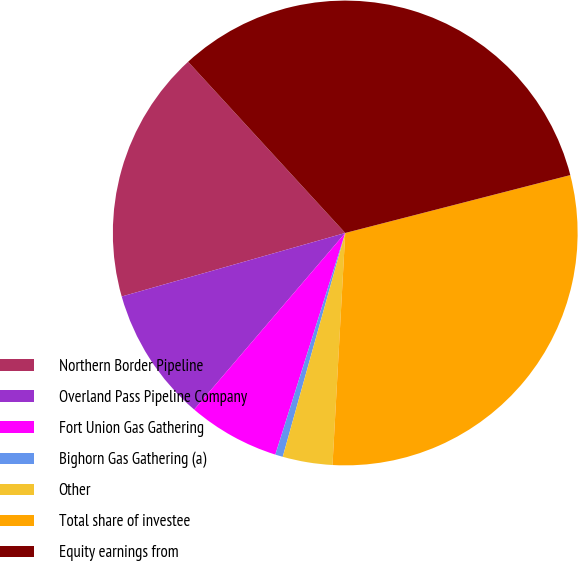Convert chart. <chart><loc_0><loc_0><loc_500><loc_500><pie_chart><fcel>Northern Border Pipeline<fcel>Overland Pass Pipeline Company<fcel>Fort Union Gas Gathering<fcel>Bighorn Gas Gathering (a)<fcel>Other<fcel>Total share of investee<fcel>Equity earnings from<nl><fcel>17.59%<fcel>9.33%<fcel>6.4%<fcel>0.53%<fcel>3.46%<fcel>29.88%<fcel>32.81%<nl></chart> 